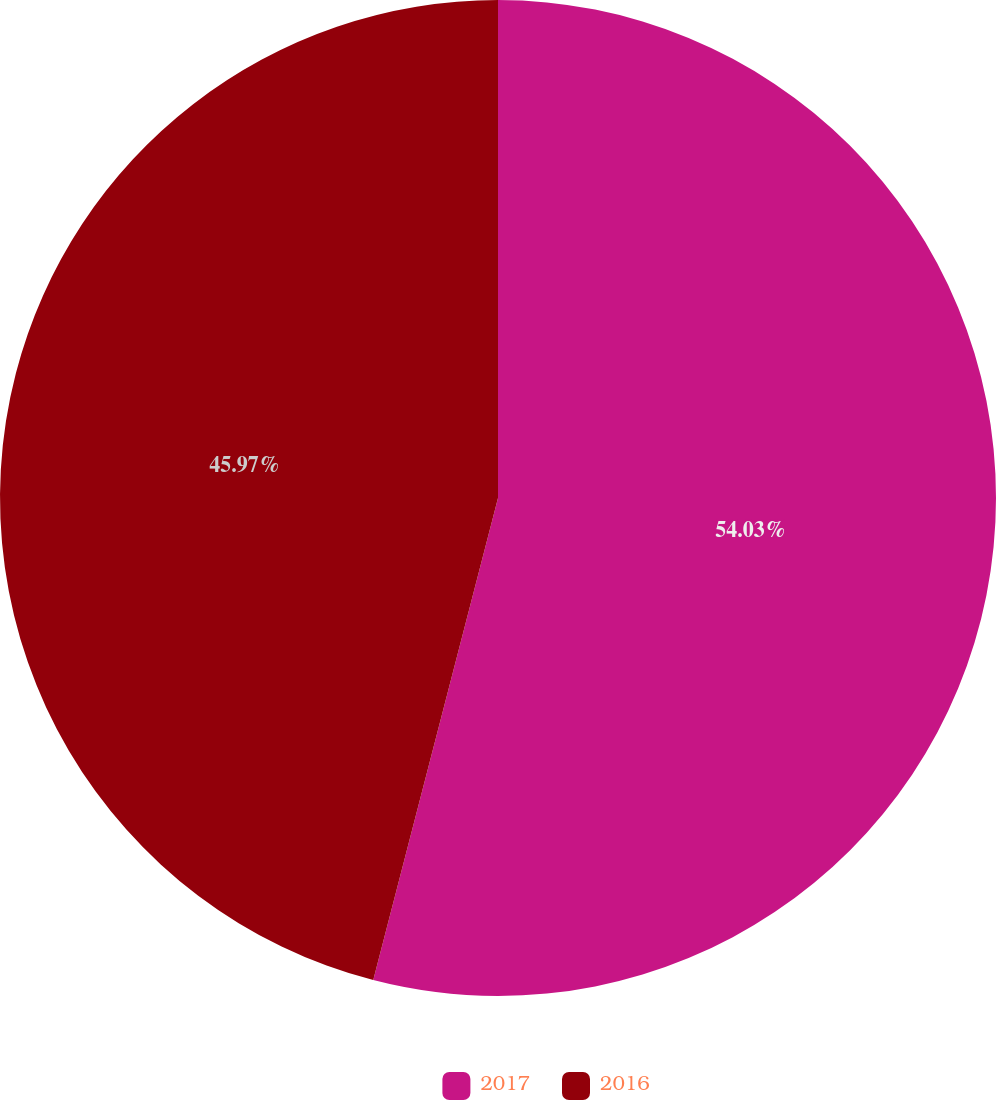<chart> <loc_0><loc_0><loc_500><loc_500><pie_chart><fcel>2017<fcel>2016<nl><fcel>54.03%<fcel>45.97%<nl></chart> 